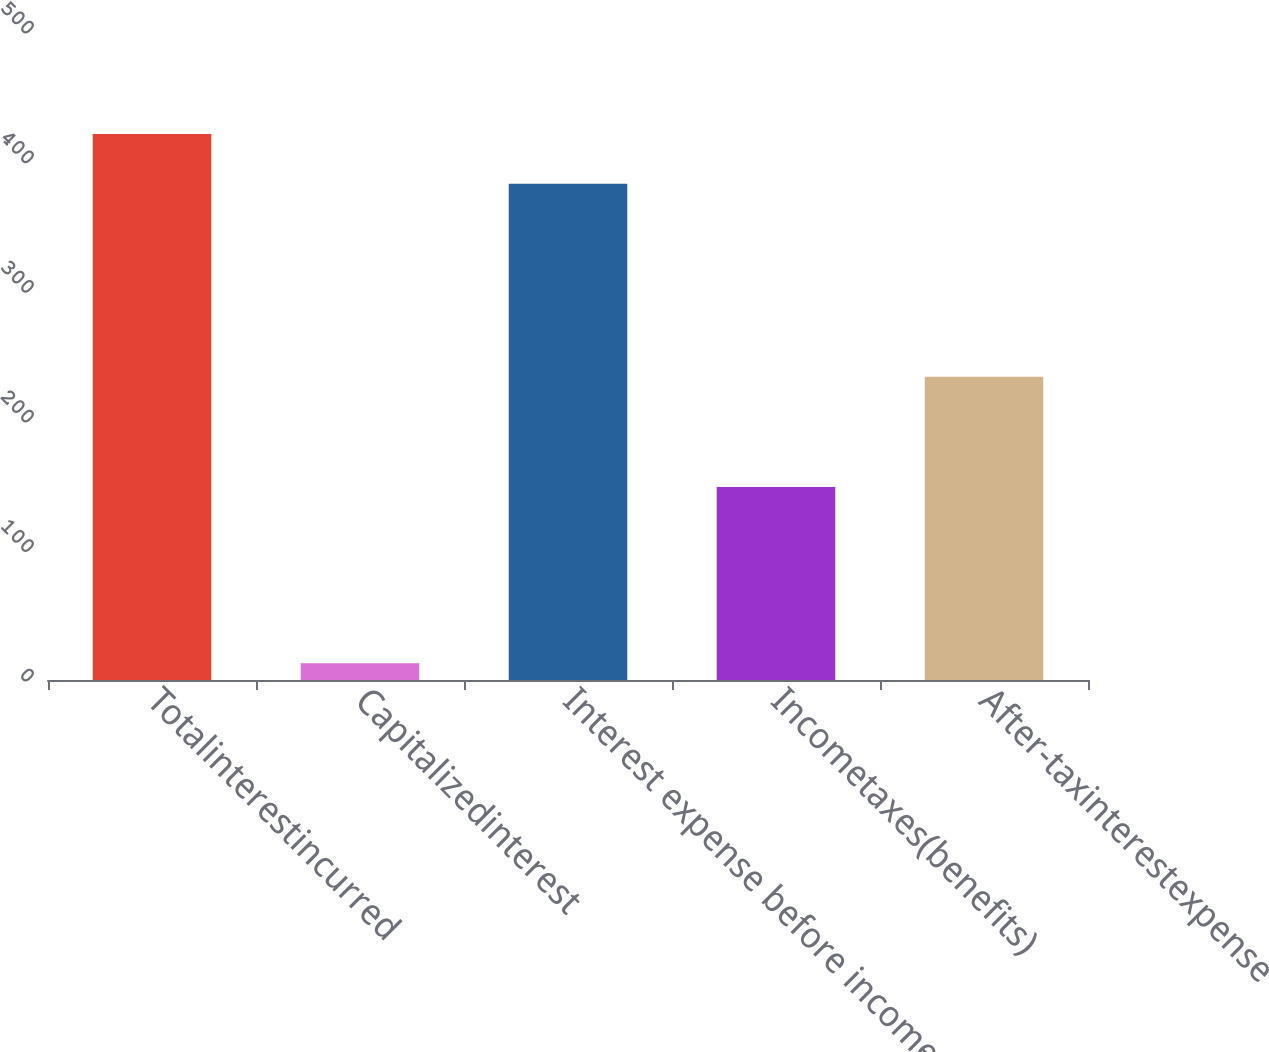Convert chart to OTSL. <chart><loc_0><loc_0><loc_500><loc_500><bar_chart><fcel>Totalinterestincurred<fcel>Capitalizedinterest<fcel>Interest expense before income<fcel>Incometaxes(benefits)<fcel>After-taxinterestexpense<nl><fcel>421.3<fcel>13<fcel>383<fcel>149<fcel>234<nl></chart> 